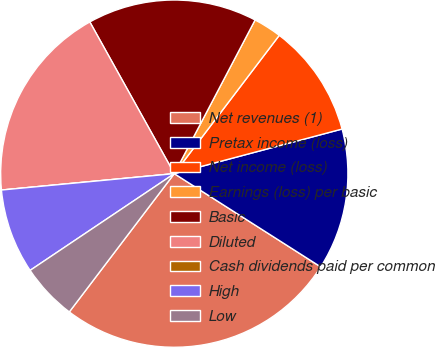Convert chart. <chart><loc_0><loc_0><loc_500><loc_500><pie_chart><fcel>Net revenues (1)<fcel>Pretax income (loss)<fcel>Net income (loss)<fcel>Earnings (loss) per basic<fcel>Basic<fcel>Diluted<fcel>Cash dividends paid per common<fcel>High<fcel>Low<nl><fcel>26.31%<fcel>13.16%<fcel>10.53%<fcel>2.63%<fcel>15.79%<fcel>18.42%<fcel>0.0%<fcel>7.9%<fcel>5.26%<nl></chart> 